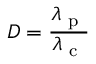Convert formula to latex. <formula><loc_0><loc_0><loc_500><loc_500>D = \frac { \lambda _ { p } } { \lambda _ { c } }</formula> 